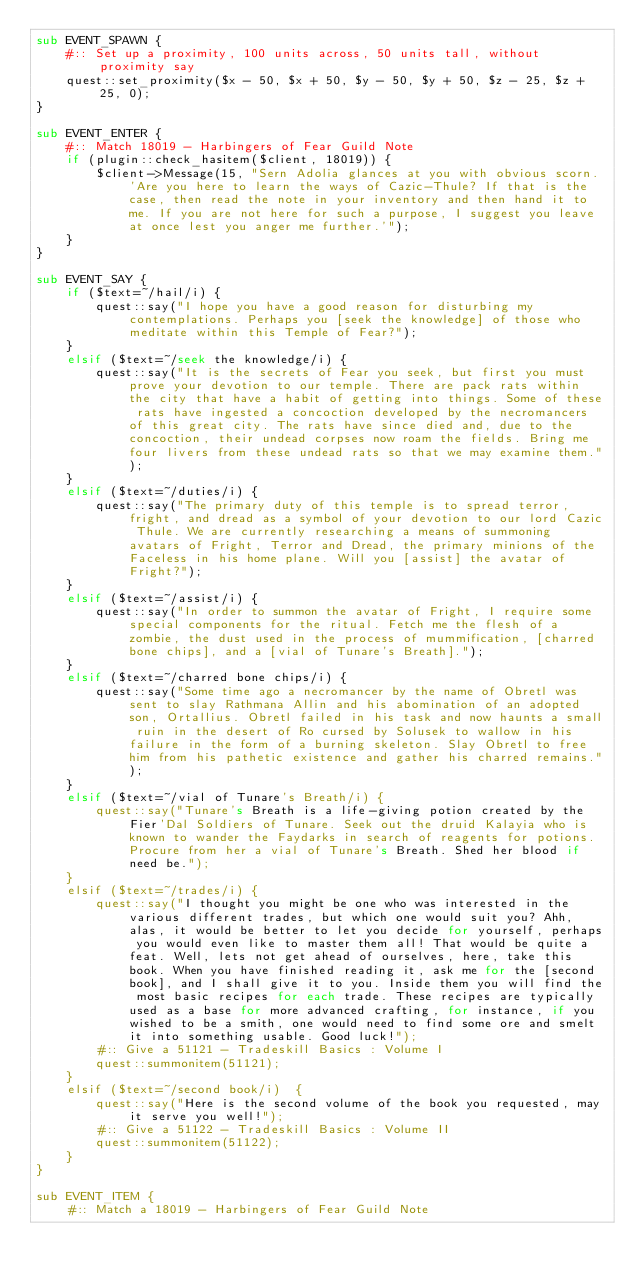Convert code to text. <code><loc_0><loc_0><loc_500><loc_500><_Perl_>sub EVENT_SPAWN {
	#:: Set up a proximity, 100 units across, 50 units tall, without proximity say
	quest::set_proximity($x - 50, $x + 50, $y - 50, $y + 50, $z - 25, $z + 25, 0);
}

sub EVENT_ENTER {
	#:: Match 18019 - Harbingers of Fear Guild Note
	if (plugin::check_hasitem($client, 18019)) { 
		$client->Message(15, "Sern Adolia glances at you with obvious scorn. 'Are you here to learn the ways of Cazic-Thule? If that is the case, then read the note in your inventory and then hand it to me. If you are not here for such a purpose, I suggest you leave at once lest you anger me further.'");
	}
}

sub EVENT_SAY {
	if ($text=~/hail/i) {
		quest::say("I hope you have a good reason for disturbing my contemplations. Perhaps you [seek the knowledge] of those who meditate within this Temple of Fear?");
	}
	elsif ($text=~/seek the knowledge/i) {
		quest::say("It is the secrets of Fear you seek, but first you must prove your devotion to our temple. There are pack rats within the city that have a habit of getting into things. Some of these rats have ingested a concoction developed by the necromancers of this great city. The rats have since died and, due to the concoction, their undead corpses now roam the fields. Bring me four livers from these undead rats so that we may examine them.");
	}
	elsif ($text=~/duties/i) {
		quest::say("The primary duty of this temple is to spread terror, fright, and dread as a symbol of your devotion to our lord Cazic Thule. We are currently researching a means of summoning avatars of Fright, Terror and Dread, the primary minions of the Faceless in his home plane. Will you [assist] the avatar of Fright?");
	}
	elsif ($text=~/assist/i) {
		quest::say("In order to summon the avatar of Fright, I require some special components for the ritual. Fetch me the flesh of a zombie, the dust used in the process of mummification, [charred bone chips], and a [vial of Tunare's Breath].");
	}
	elsif ($text=~/charred bone chips/i) {
		quest::say("Some time ago a necromancer by the name of Obretl was sent to slay Rathmana Allin and his abomination of an adopted son, Ortallius. Obretl failed in his task and now haunts a small ruin in the desert of Ro cursed by Solusek to wallow in his failure in the form of a burning skeleton. Slay Obretl to free him from his pathetic existence and gather his charred remains.");
	}
	elsif ($text=~/vial of Tunare's Breath/i) {
		quest::say("Tunare's Breath is a life-giving potion created by the Fier'Dal Soldiers of Tunare. Seek out the druid Kalayia who is known to wander the Faydarks in search of reagents for potions. Procure from her a vial of Tunare's Breath. Shed her blood if need be.");
	}
	elsif ($text=~/trades/i) {
		quest::say("I thought you might be one who was interested in the various different trades, but which one would suit you? Ahh, alas, it would be better to let you decide for yourself, perhaps you would even like to master them all! That would be quite a feat. Well, lets not get ahead of ourselves, here, take this book. When you have finished reading it, ask me for the [second book], and I shall give it to you. Inside them you will find the most basic recipes for each trade. These recipes are typically used as a base for more advanced crafting, for instance, if you wished to be a smith, one would need to find some ore and smelt it into something usable. Good luck!");
		#:: Give a 51121 - Tradeskill Basics : Volume I
		quest::summonitem(51121);
	}
	elsif ($text=~/second book/i)  {
		quest::say("Here is the second volume of the book you requested, may it serve you well!");
		#:: Give a 51122 - Tradeskill Basics : Volume II
		quest::summonitem(51122);
	}
}

sub EVENT_ITEM {
	#:: Match a 18019 - Harbingers of Fear Guild Note</code> 